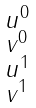Convert formula to latex. <formula><loc_0><loc_0><loc_500><loc_500>\begin{smallmatrix} u ^ { 0 } \\ v ^ { 0 } \\ u ^ { 1 } \\ v ^ { 1 } \\ \end{smallmatrix}</formula> 